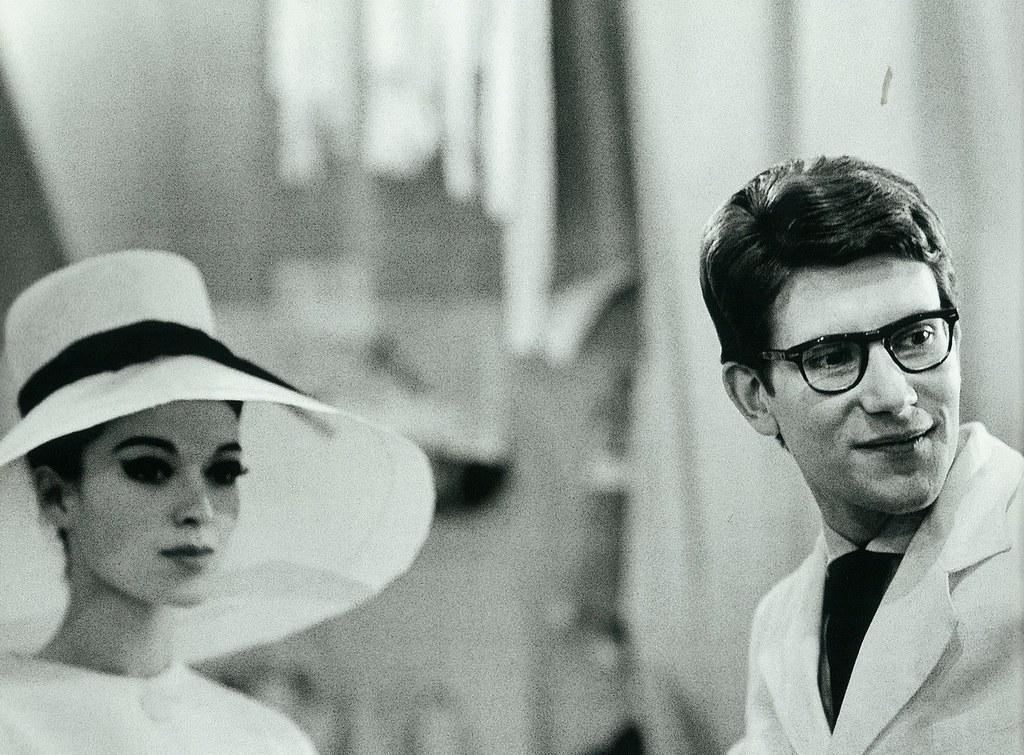Could you give a brief overview of what you see in this image? This is a black and white image. In this image we can see a man and a woman. 